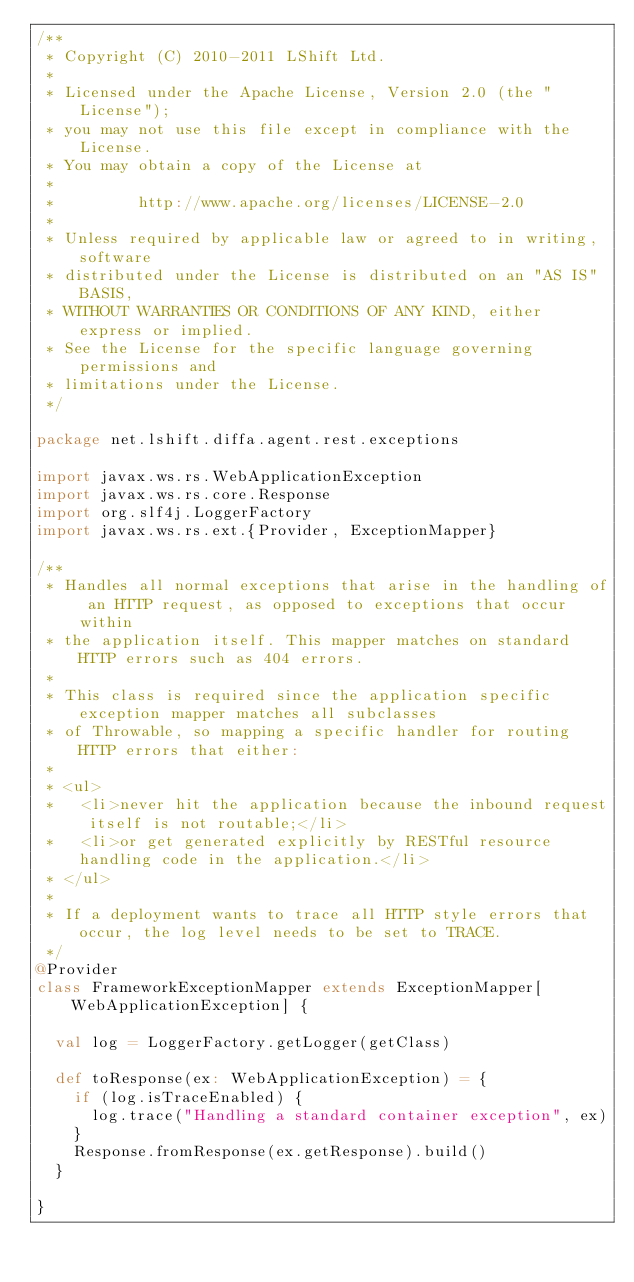<code> <loc_0><loc_0><loc_500><loc_500><_Scala_>/**
 * Copyright (C) 2010-2011 LShift Ltd.
 *
 * Licensed under the Apache License, Version 2.0 (the "License");
 * you may not use this file except in compliance with the License.
 * You may obtain a copy of the License at
 *
 *         http://www.apache.org/licenses/LICENSE-2.0
 *
 * Unless required by applicable law or agreed to in writing, software
 * distributed under the License is distributed on an "AS IS" BASIS,
 * WITHOUT WARRANTIES OR CONDITIONS OF ANY KIND, either express or implied.
 * See the License for the specific language governing permissions and
 * limitations under the License.
 */

package net.lshift.diffa.agent.rest.exceptions

import javax.ws.rs.WebApplicationException
import javax.ws.rs.core.Response
import org.slf4j.LoggerFactory
import javax.ws.rs.ext.{Provider, ExceptionMapper}

/**
 * Handles all normal exceptions that arise in the handling of an HTTP request, as opposed to exceptions that occur within
 * the application itself. This mapper matches on standard HTTP errors such as 404 errors.
 *
 * This class is required since the application specific exception mapper matches all subclasses
 * of Throwable, so mapping a specific handler for routing HTTP errors that either:
 *
 * <ul>
 *   <li>never hit the application because the inbound request itself is not routable;</li>
 *   <li>or get generated explicitly by RESTful resource handling code in the application.</li>
 * </ul>
 *
 * If a deployment wants to trace all HTTP style errors that occur, the log level needs to be set to TRACE.
 */
@Provider
class FrameworkExceptionMapper extends ExceptionMapper[WebApplicationException] {

  val log = LoggerFactory.getLogger(getClass)

  def toResponse(ex: WebApplicationException) = {
    if (log.isTraceEnabled) {
      log.trace("Handling a standard container exception", ex)
    }
    Response.fromResponse(ex.getResponse).build()
  }

}</code> 